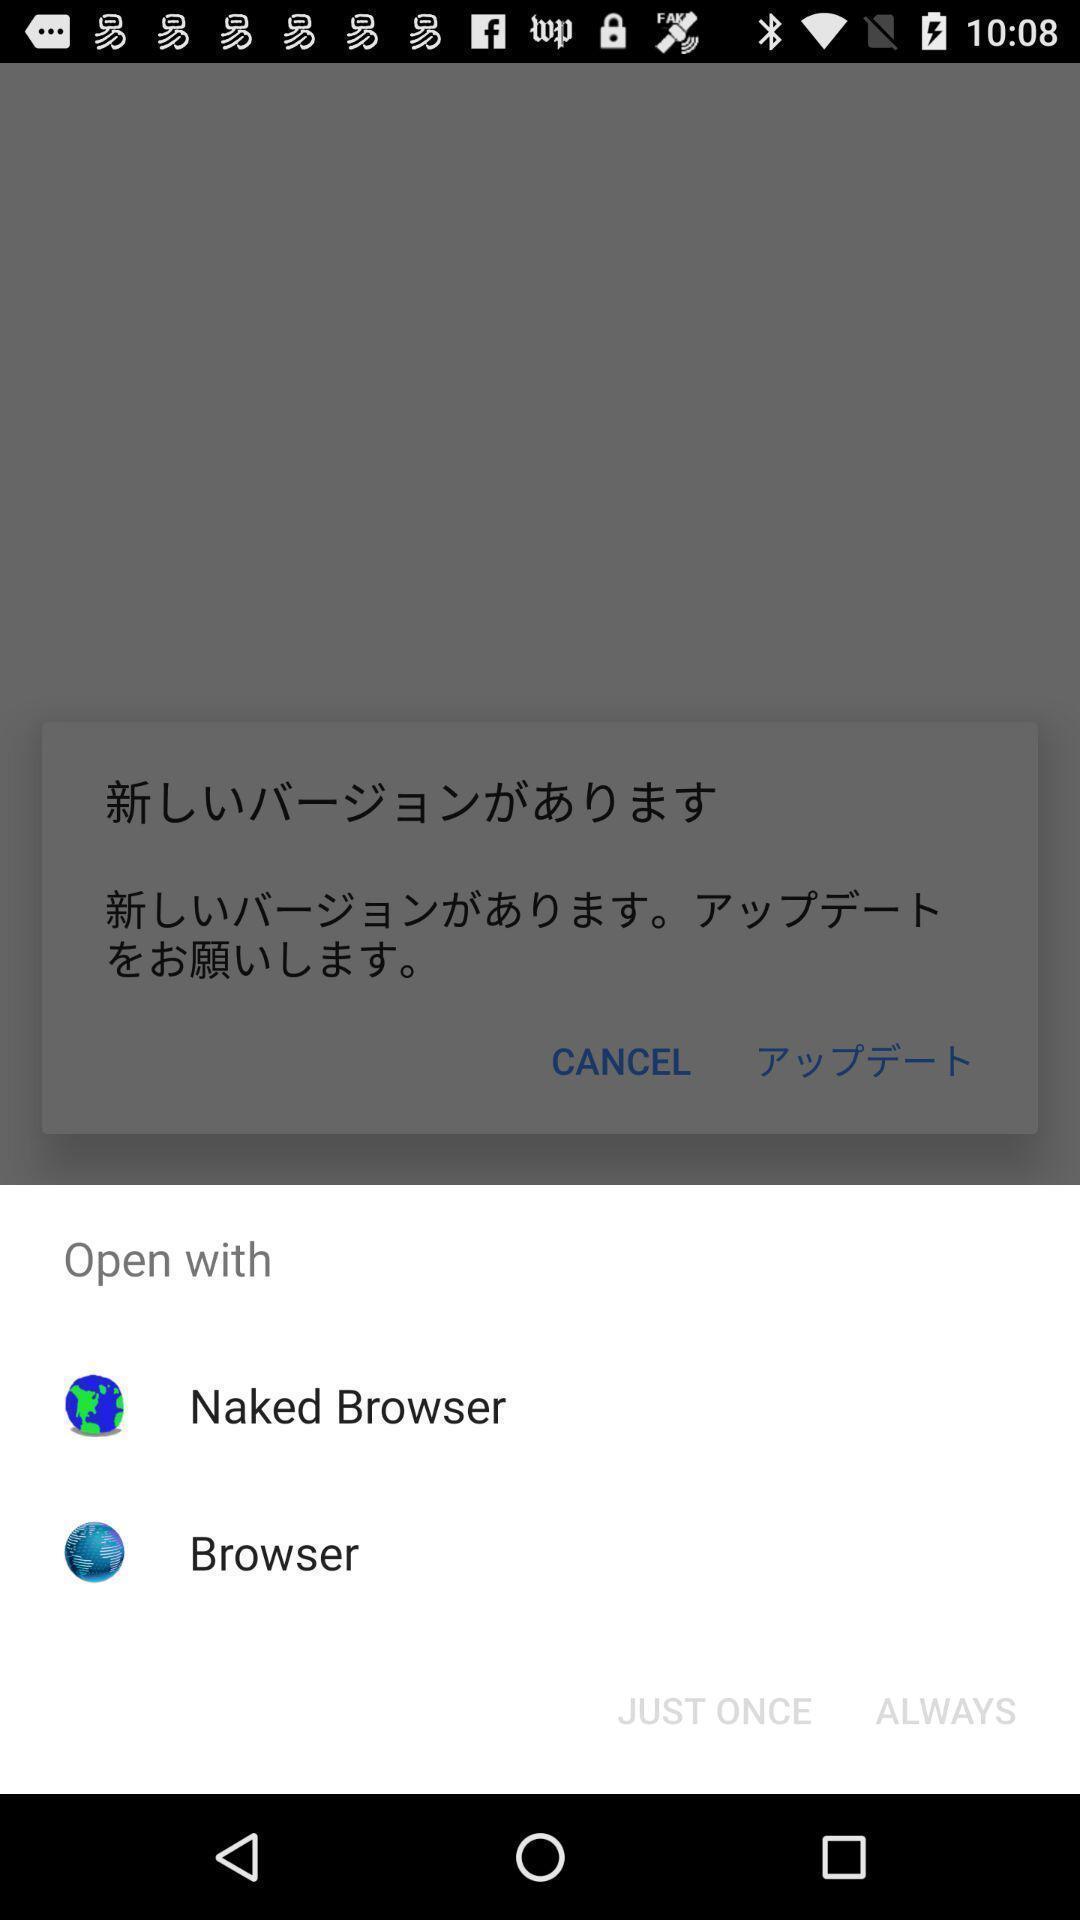Tell me about the visual elements in this screen capture. Pop-up showing the app options to open. 